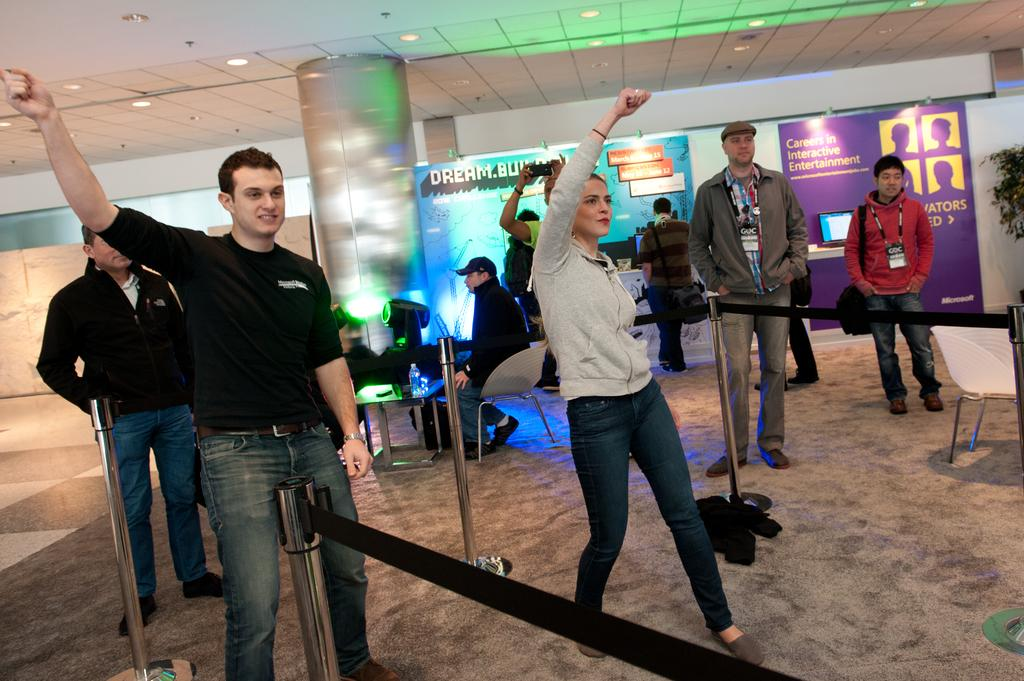What is happening in the center of the image? There are persons standing in the center of the image. What is the surface that the persons are standing on? There is a floor visible in the image. What can be seen in the background of the image? There is a pillar, persons, a chair, a table, a light, and a wall in the background of the image. Can you tell me how many pens are being used by the persons in the image? There is no mention of pens in the image; the focus is on the persons standing and the background elements. What type of hands are the persons using to interact with the objects in the image? There is no specific information about the hands of the persons in the image, but they are likely using their hands to hold or interact with the objects. 